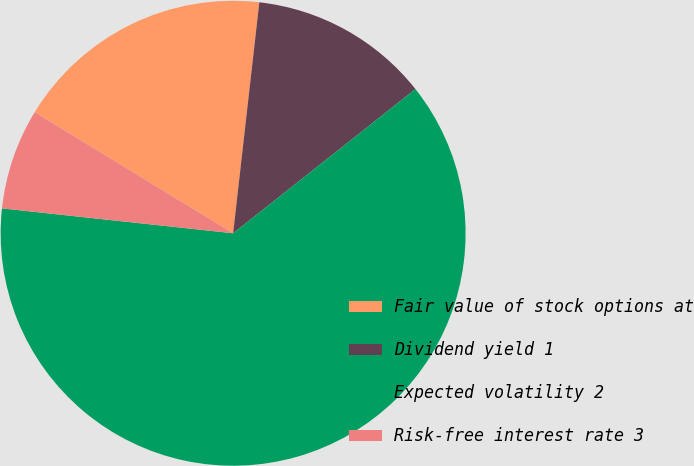Convert chart to OTSL. <chart><loc_0><loc_0><loc_500><loc_500><pie_chart><fcel>Fair value of stock options at<fcel>Dividend yield 1<fcel>Expected volatility 2<fcel>Risk-free interest rate 3<nl><fcel>18.08%<fcel>12.55%<fcel>62.35%<fcel>7.01%<nl></chart> 